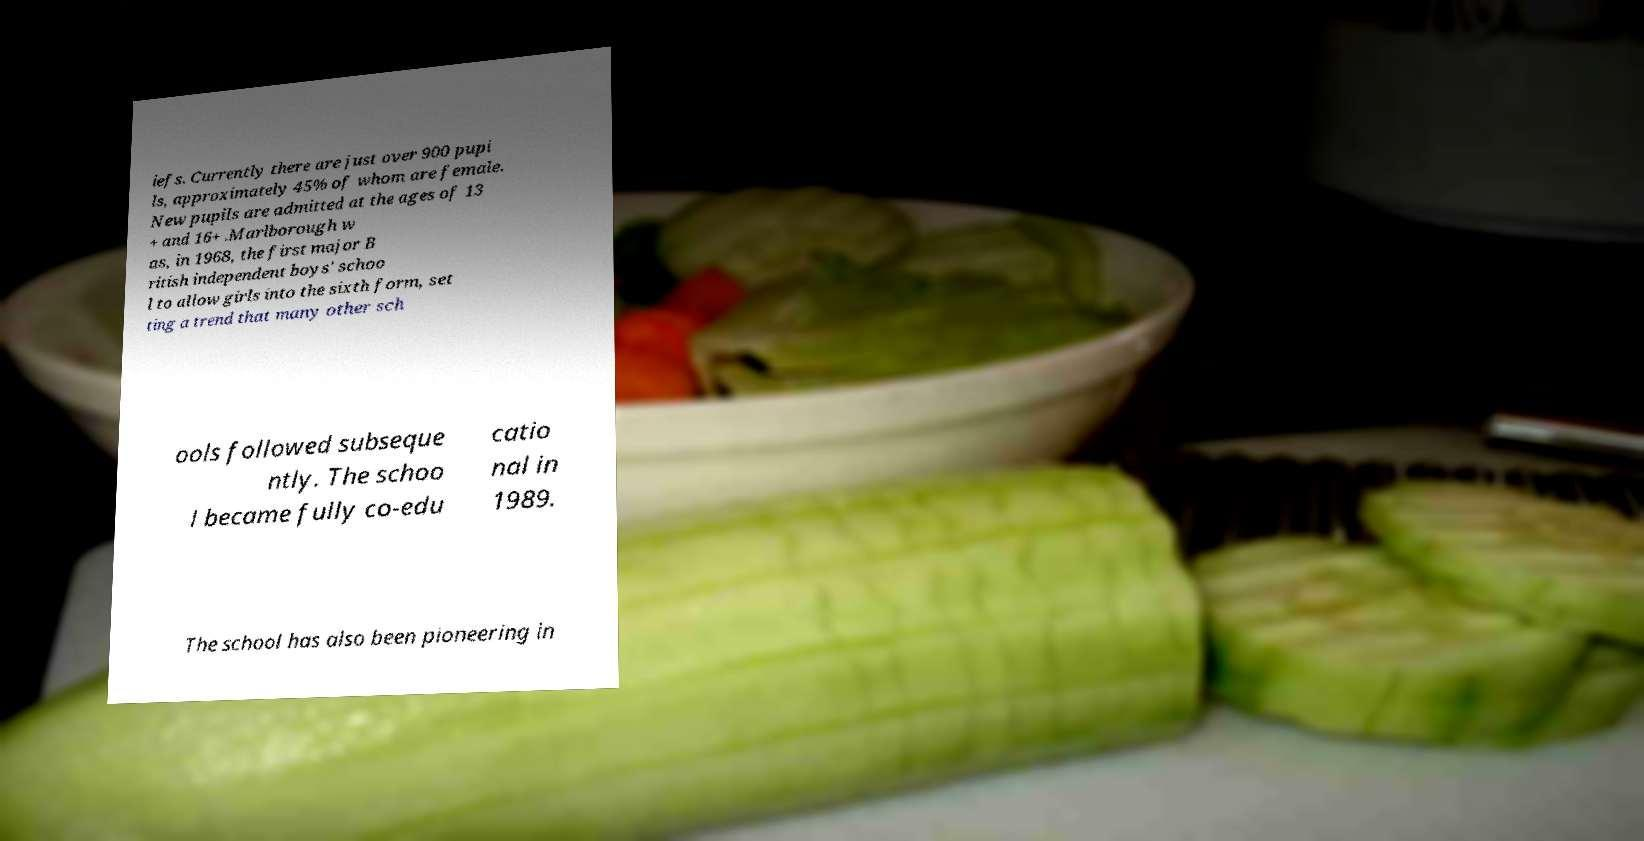Can you accurately transcribe the text from the provided image for me? iefs. Currently there are just over 900 pupi ls, approximately 45% of whom are female. New pupils are admitted at the ages of 13 + and 16+ .Marlborough w as, in 1968, the first major B ritish independent boys' schoo l to allow girls into the sixth form, set ting a trend that many other sch ools followed subseque ntly. The schoo l became fully co-edu catio nal in 1989. The school has also been pioneering in 